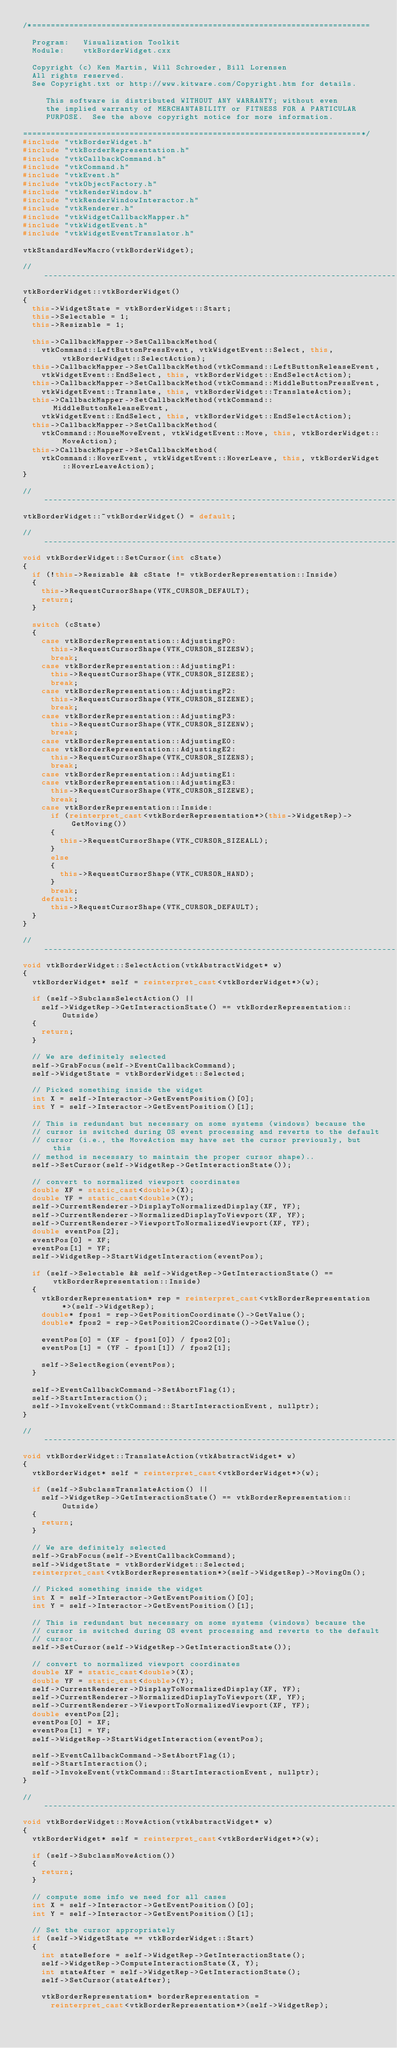Convert code to text. <code><loc_0><loc_0><loc_500><loc_500><_C++_>/*=========================================================================

  Program:   Visualization Toolkit
  Module:    vtkBorderWidget.cxx

  Copyright (c) Ken Martin, Will Schroeder, Bill Lorensen
  All rights reserved.
  See Copyright.txt or http://www.kitware.com/Copyright.htm for details.

     This software is distributed WITHOUT ANY WARRANTY; without even
     the implied warranty of MERCHANTABILITY or FITNESS FOR A PARTICULAR
     PURPOSE.  See the above copyright notice for more information.

=========================================================================*/
#include "vtkBorderWidget.h"
#include "vtkBorderRepresentation.h"
#include "vtkCallbackCommand.h"
#include "vtkCommand.h"
#include "vtkEvent.h"
#include "vtkObjectFactory.h"
#include "vtkRenderWindow.h"
#include "vtkRenderWindowInteractor.h"
#include "vtkRenderer.h"
#include "vtkWidgetCallbackMapper.h"
#include "vtkWidgetEvent.h"
#include "vtkWidgetEventTranslator.h"

vtkStandardNewMacro(vtkBorderWidget);

//------------------------------------------------------------------------------
vtkBorderWidget::vtkBorderWidget()
{
  this->WidgetState = vtkBorderWidget::Start;
  this->Selectable = 1;
  this->Resizable = 1;

  this->CallbackMapper->SetCallbackMethod(
    vtkCommand::LeftButtonPressEvent, vtkWidgetEvent::Select, this, vtkBorderWidget::SelectAction);
  this->CallbackMapper->SetCallbackMethod(vtkCommand::LeftButtonReleaseEvent,
    vtkWidgetEvent::EndSelect, this, vtkBorderWidget::EndSelectAction);
  this->CallbackMapper->SetCallbackMethod(vtkCommand::MiddleButtonPressEvent,
    vtkWidgetEvent::Translate, this, vtkBorderWidget::TranslateAction);
  this->CallbackMapper->SetCallbackMethod(vtkCommand::MiddleButtonReleaseEvent,
    vtkWidgetEvent::EndSelect, this, vtkBorderWidget::EndSelectAction);
  this->CallbackMapper->SetCallbackMethod(
    vtkCommand::MouseMoveEvent, vtkWidgetEvent::Move, this, vtkBorderWidget::MoveAction);
  this->CallbackMapper->SetCallbackMethod(
    vtkCommand::HoverEvent, vtkWidgetEvent::HoverLeave, this, vtkBorderWidget::HoverLeaveAction);
}

//------------------------------------------------------------------------------
vtkBorderWidget::~vtkBorderWidget() = default;

//------------------------------------------------------------------------------
void vtkBorderWidget::SetCursor(int cState)
{
  if (!this->Resizable && cState != vtkBorderRepresentation::Inside)
  {
    this->RequestCursorShape(VTK_CURSOR_DEFAULT);
    return;
  }

  switch (cState)
  {
    case vtkBorderRepresentation::AdjustingP0:
      this->RequestCursorShape(VTK_CURSOR_SIZESW);
      break;
    case vtkBorderRepresentation::AdjustingP1:
      this->RequestCursorShape(VTK_CURSOR_SIZESE);
      break;
    case vtkBorderRepresentation::AdjustingP2:
      this->RequestCursorShape(VTK_CURSOR_SIZENE);
      break;
    case vtkBorderRepresentation::AdjustingP3:
      this->RequestCursorShape(VTK_CURSOR_SIZENW);
      break;
    case vtkBorderRepresentation::AdjustingE0:
    case vtkBorderRepresentation::AdjustingE2:
      this->RequestCursorShape(VTK_CURSOR_SIZENS);
      break;
    case vtkBorderRepresentation::AdjustingE1:
    case vtkBorderRepresentation::AdjustingE3:
      this->RequestCursorShape(VTK_CURSOR_SIZEWE);
      break;
    case vtkBorderRepresentation::Inside:
      if (reinterpret_cast<vtkBorderRepresentation*>(this->WidgetRep)->GetMoving())
      {
        this->RequestCursorShape(VTK_CURSOR_SIZEALL);
      }
      else
      {
        this->RequestCursorShape(VTK_CURSOR_HAND);
      }
      break;
    default:
      this->RequestCursorShape(VTK_CURSOR_DEFAULT);
  }
}

//------------------------------------------------------------------------------
void vtkBorderWidget::SelectAction(vtkAbstractWidget* w)
{
  vtkBorderWidget* self = reinterpret_cast<vtkBorderWidget*>(w);

  if (self->SubclassSelectAction() ||
    self->WidgetRep->GetInteractionState() == vtkBorderRepresentation::Outside)
  {
    return;
  }

  // We are definitely selected
  self->GrabFocus(self->EventCallbackCommand);
  self->WidgetState = vtkBorderWidget::Selected;

  // Picked something inside the widget
  int X = self->Interactor->GetEventPosition()[0];
  int Y = self->Interactor->GetEventPosition()[1];

  // This is redundant but necessary on some systems (windows) because the
  // cursor is switched during OS event processing and reverts to the default
  // cursor (i.e., the MoveAction may have set the cursor previously, but this
  // method is necessary to maintain the proper cursor shape)..
  self->SetCursor(self->WidgetRep->GetInteractionState());

  // convert to normalized viewport coordinates
  double XF = static_cast<double>(X);
  double YF = static_cast<double>(Y);
  self->CurrentRenderer->DisplayToNormalizedDisplay(XF, YF);
  self->CurrentRenderer->NormalizedDisplayToViewport(XF, YF);
  self->CurrentRenderer->ViewportToNormalizedViewport(XF, YF);
  double eventPos[2];
  eventPos[0] = XF;
  eventPos[1] = YF;
  self->WidgetRep->StartWidgetInteraction(eventPos);

  if (self->Selectable && self->WidgetRep->GetInteractionState() == vtkBorderRepresentation::Inside)
  {
    vtkBorderRepresentation* rep = reinterpret_cast<vtkBorderRepresentation*>(self->WidgetRep);
    double* fpos1 = rep->GetPositionCoordinate()->GetValue();
    double* fpos2 = rep->GetPosition2Coordinate()->GetValue();

    eventPos[0] = (XF - fpos1[0]) / fpos2[0];
    eventPos[1] = (YF - fpos1[1]) / fpos2[1];

    self->SelectRegion(eventPos);
  }

  self->EventCallbackCommand->SetAbortFlag(1);
  self->StartInteraction();
  self->InvokeEvent(vtkCommand::StartInteractionEvent, nullptr);
}

//------------------------------------------------------------------------------
void vtkBorderWidget::TranslateAction(vtkAbstractWidget* w)
{
  vtkBorderWidget* self = reinterpret_cast<vtkBorderWidget*>(w);

  if (self->SubclassTranslateAction() ||
    self->WidgetRep->GetInteractionState() == vtkBorderRepresentation::Outside)
  {
    return;
  }

  // We are definitely selected
  self->GrabFocus(self->EventCallbackCommand);
  self->WidgetState = vtkBorderWidget::Selected;
  reinterpret_cast<vtkBorderRepresentation*>(self->WidgetRep)->MovingOn();

  // Picked something inside the widget
  int X = self->Interactor->GetEventPosition()[0];
  int Y = self->Interactor->GetEventPosition()[1];

  // This is redundant but necessary on some systems (windows) because the
  // cursor is switched during OS event processing and reverts to the default
  // cursor.
  self->SetCursor(self->WidgetRep->GetInteractionState());

  // convert to normalized viewport coordinates
  double XF = static_cast<double>(X);
  double YF = static_cast<double>(Y);
  self->CurrentRenderer->DisplayToNormalizedDisplay(XF, YF);
  self->CurrentRenderer->NormalizedDisplayToViewport(XF, YF);
  self->CurrentRenderer->ViewportToNormalizedViewport(XF, YF);
  double eventPos[2];
  eventPos[0] = XF;
  eventPos[1] = YF;
  self->WidgetRep->StartWidgetInteraction(eventPos);

  self->EventCallbackCommand->SetAbortFlag(1);
  self->StartInteraction();
  self->InvokeEvent(vtkCommand::StartInteractionEvent, nullptr);
}

//------------------------------------------------------------------------------
void vtkBorderWidget::MoveAction(vtkAbstractWidget* w)
{
  vtkBorderWidget* self = reinterpret_cast<vtkBorderWidget*>(w);

  if (self->SubclassMoveAction())
  {
    return;
  }

  // compute some info we need for all cases
  int X = self->Interactor->GetEventPosition()[0];
  int Y = self->Interactor->GetEventPosition()[1];

  // Set the cursor appropriately
  if (self->WidgetState == vtkBorderWidget::Start)
  {
    int stateBefore = self->WidgetRep->GetInteractionState();
    self->WidgetRep->ComputeInteractionState(X, Y);
    int stateAfter = self->WidgetRep->GetInteractionState();
    self->SetCursor(stateAfter);

    vtkBorderRepresentation* borderRepresentation =
      reinterpret_cast<vtkBorderRepresentation*>(self->WidgetRep);</code> 